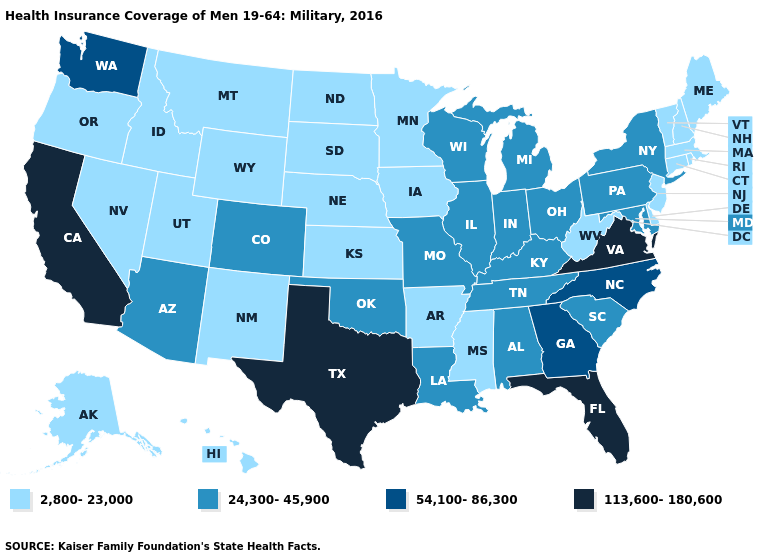Is the legend a continuous bar?
Quick response, please. No. Name the states that have a value in the range 113,600-180,600?
Write a very short answer. California, Florida, Texas, Virginia. What is the value of Wisconsin?
Write a very short answer. 24,300-45,900. Does California have the highest value in the West?
Keep it brief. Yes. Name the states that have a value in the range 24,300-45,900?
Quick response, please. Alabama, Arizona, Colorado, Illinois, Indiana, Kentucky, Louisiana, Maryland, Michigan, Missouri, New York, Ohio, Oklahoma, Pennsylvania, South Carolina, Tennessee, Wisconsin. Does Oklahoma have a higher value than Kentucky?
Give a very brief answer. No. Does Hawaii have the highest value in the USA?
Write a very short answer. No. What is the value of Utah?
Keep it brief. 2,800-23,000. What is the value of North Dakota?
Short answer required. 2,800-23,000. What is the value of Florida?
Be succinct. 113,600-180,600. Name the states that have a value in the range 2,800-23,000?
Quick response, please. Alaska, Arkansas, Connecticut, Delaware, Hawaii, Idaho, Iowa, Kansas, Maine, Massachusetts, Minnesota, Mississippi, Montana, Nebraska, Nevada, New Hampshire, New Jersey, New Mexico, North Dakota, Oregon, Rhode Island, South Dakota, Utah, Vermont, West Virginia, Wyoming. Name the states that have a value in the range 54,100-86,300?
Short answer required. Georgia, North Carolina, Washington. Which states have the lowest value in the USA?
Answer briefly. Alaska, Arkansas, Connecticut, Delaware, Hawaii, Idaho, Iowa, Kansas, Maine, Massachusetts, Minnesota, Mississippi, Montana, Nebraska, Nevada, New Hampshire, New Jersey, New Mexico, North Dakota, Oregon, Rhode Island, South Dakota, Utah, Vermont, West Virginia, Wyoming. What is the lowest value in the Northeast?
Answer briefly. 2,800-23,000. Which states have the lowest value in the MidWest?
Give a very brief answer. Iowa, Kansas, Minnesota, Nebraska, North Dakota, South Dakota. 